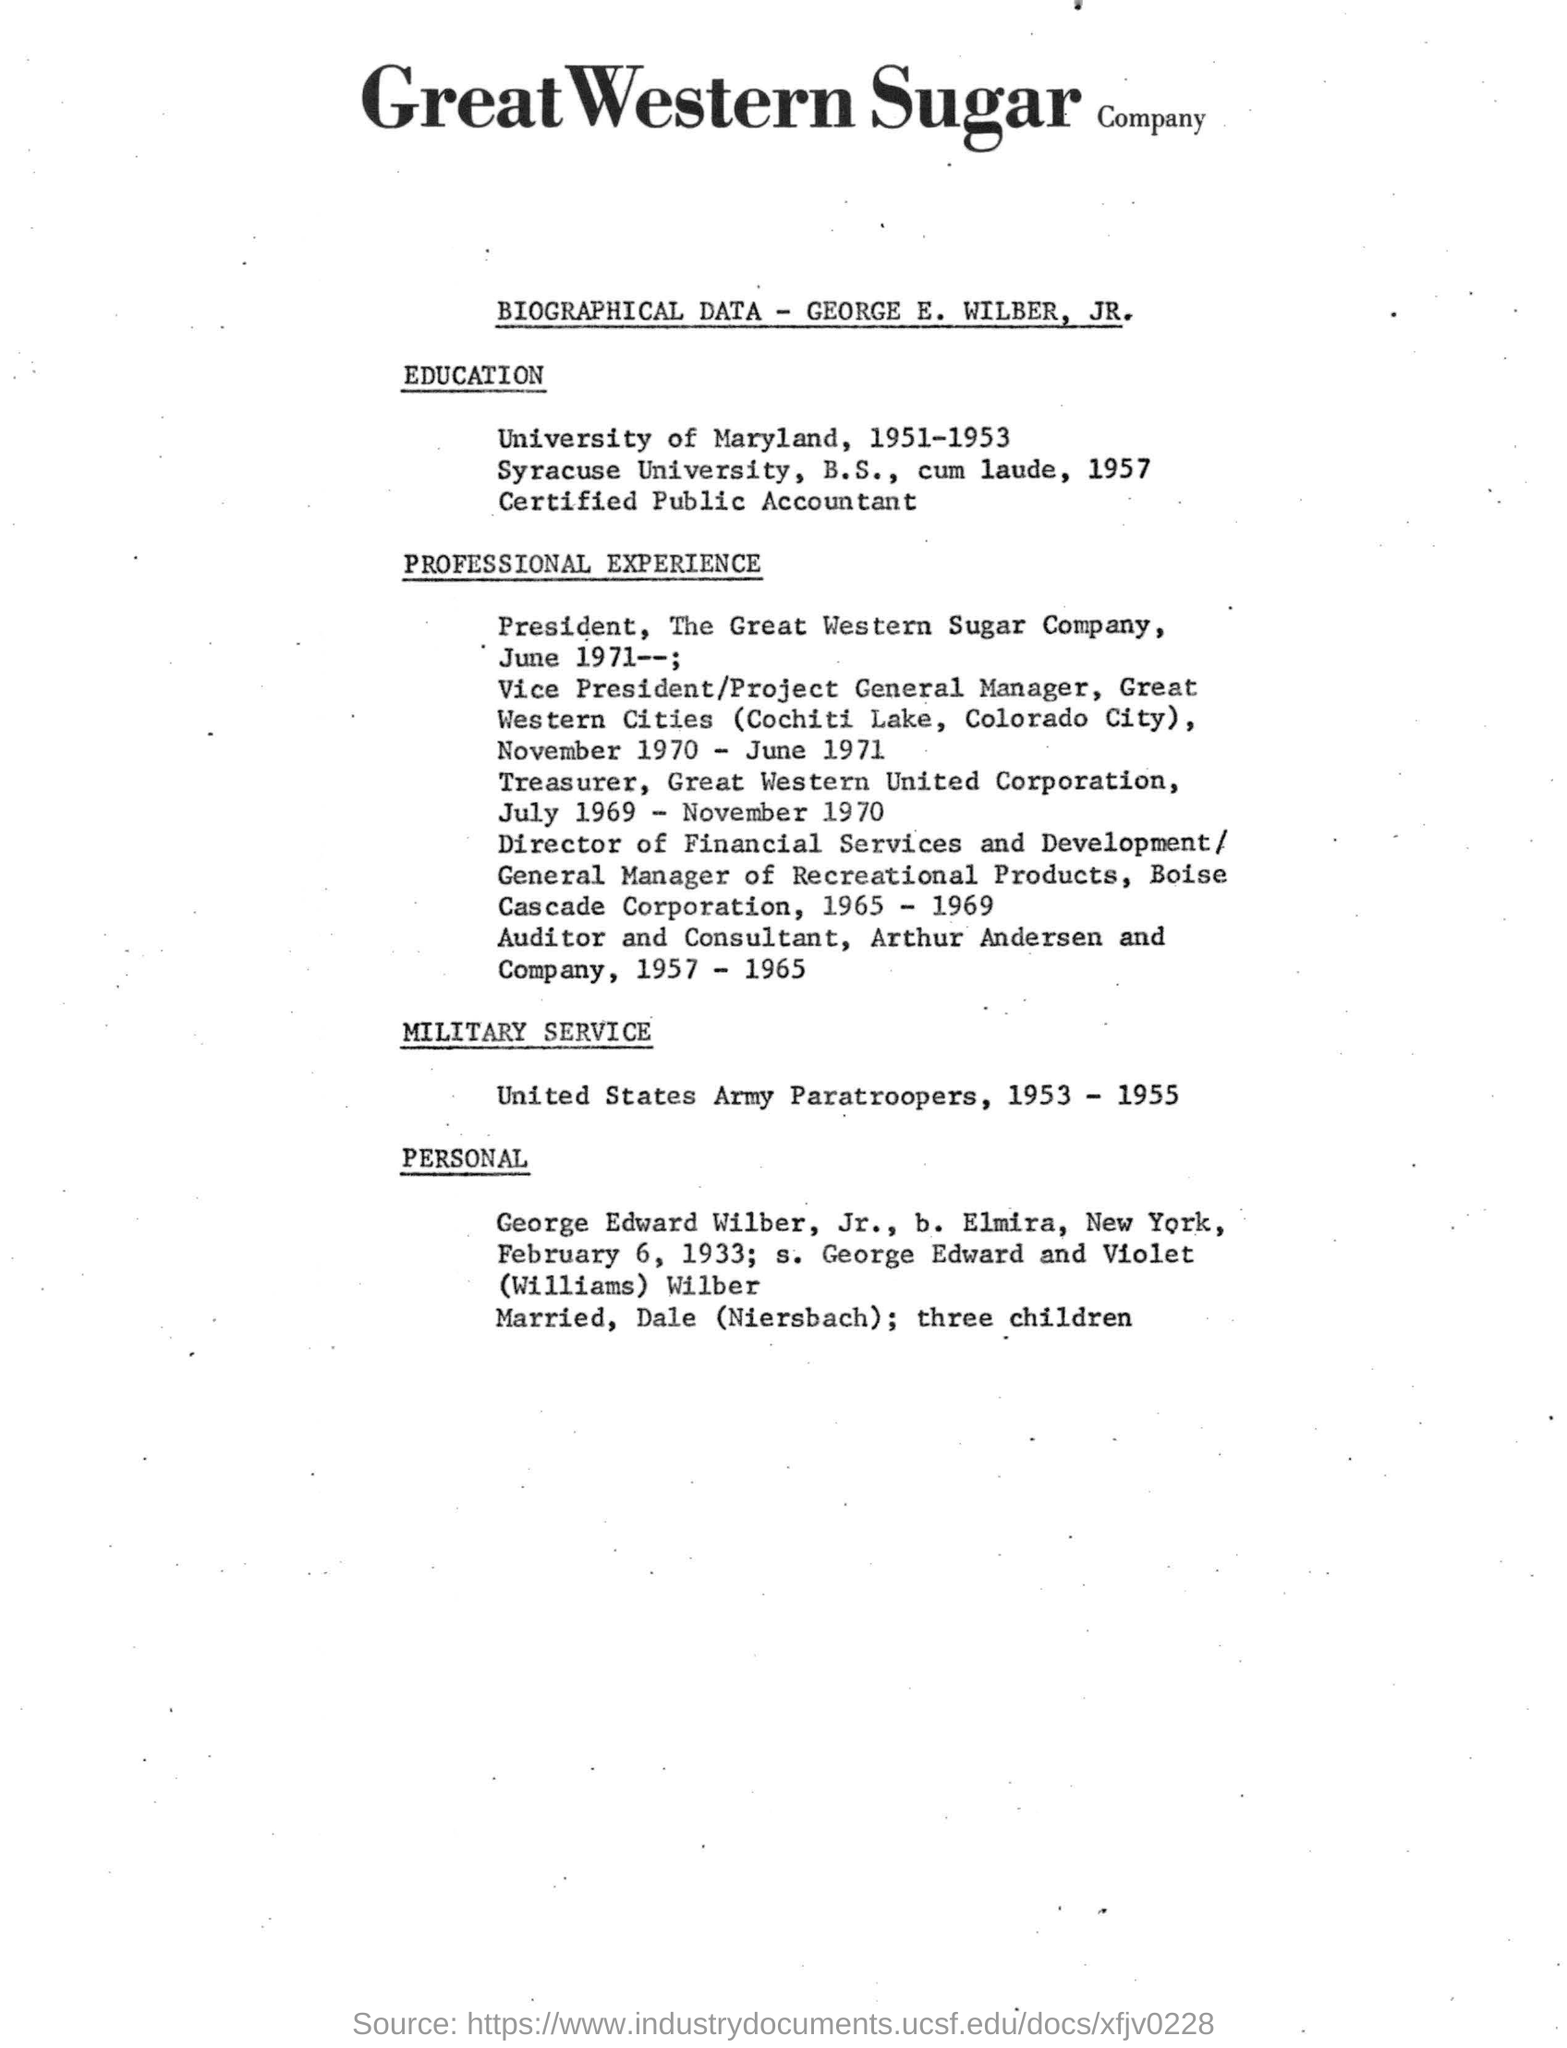Highlight a few significant elements in this photo. George worked as an auditor and consultant for Arthur Andersen and Company. It is George E. Wilber whose biographical data is mentioned. The Great Western Cities were located at Cochiti Lake, Colorado City. 